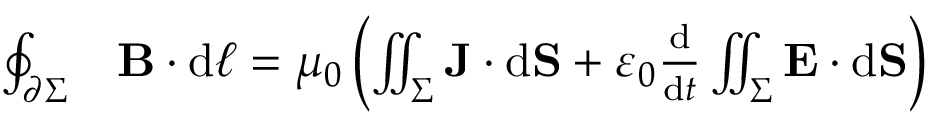<formula> <loc_0><loc_0><loc_500><loc_500>{ \begin{array} { r l } { \oint _ { \partial \Sigma } } & { B \cdot d { \ell } = \mu _ { 0 } \left ( \iint _ { \Sigma } J \cdot d S + \varepsilon _ { 0 } { \frac { d } { d t } } \iint _ { \Sigma } E \cdot d S \right ) } \end{array} }</formula> 